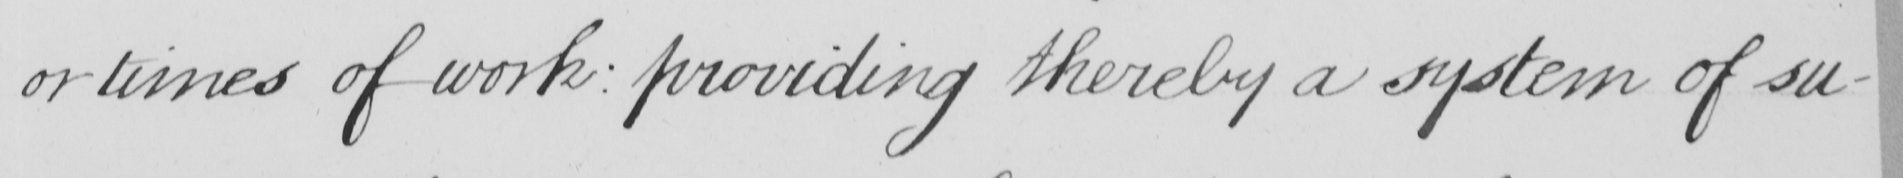Please transcribe the handwritten text in this image. or times of work :  providing thereby a system of su- 